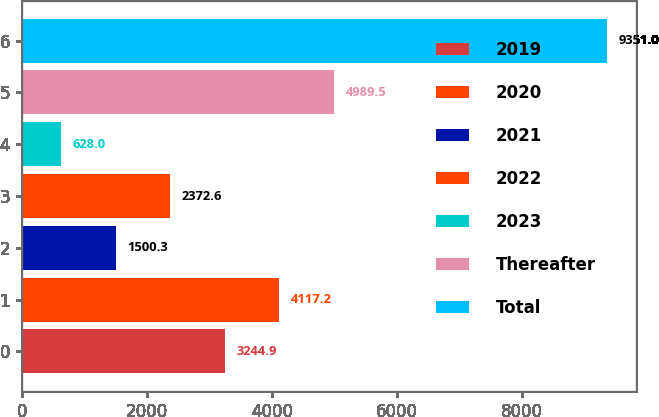<chart> <loc_0><loc_0><loc_500><loc_500><bar_chart><fcel>2019<fcel>2020<fcel>2021<fcel>2022<fcel>2023<fcel>Thereafter<fcel>Total<nl><fcel>3244.9<fcel>4117.2<fcel>1500.3<fcel>2372.6<fcel>628<fcel>4989.5<fcel>9351<nl></chart> 